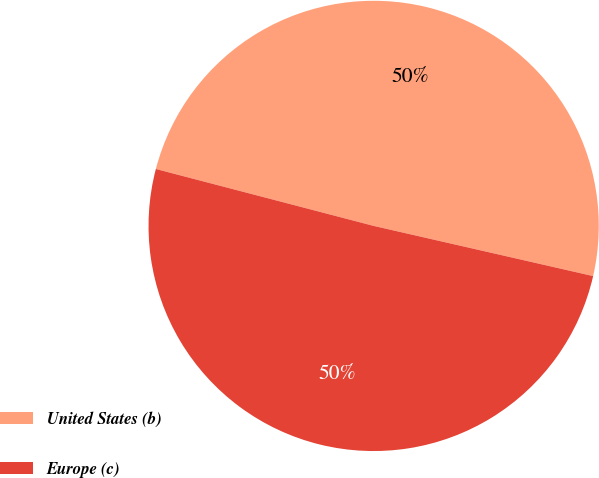Convert chart. <chart><loc_0><loc_0><loc_500><loc_500><pie_chart><fcel>United States (b)<fcel>Europe (c)<nl><fcel>49.51%<fcel>50.49%<nl></chart> 